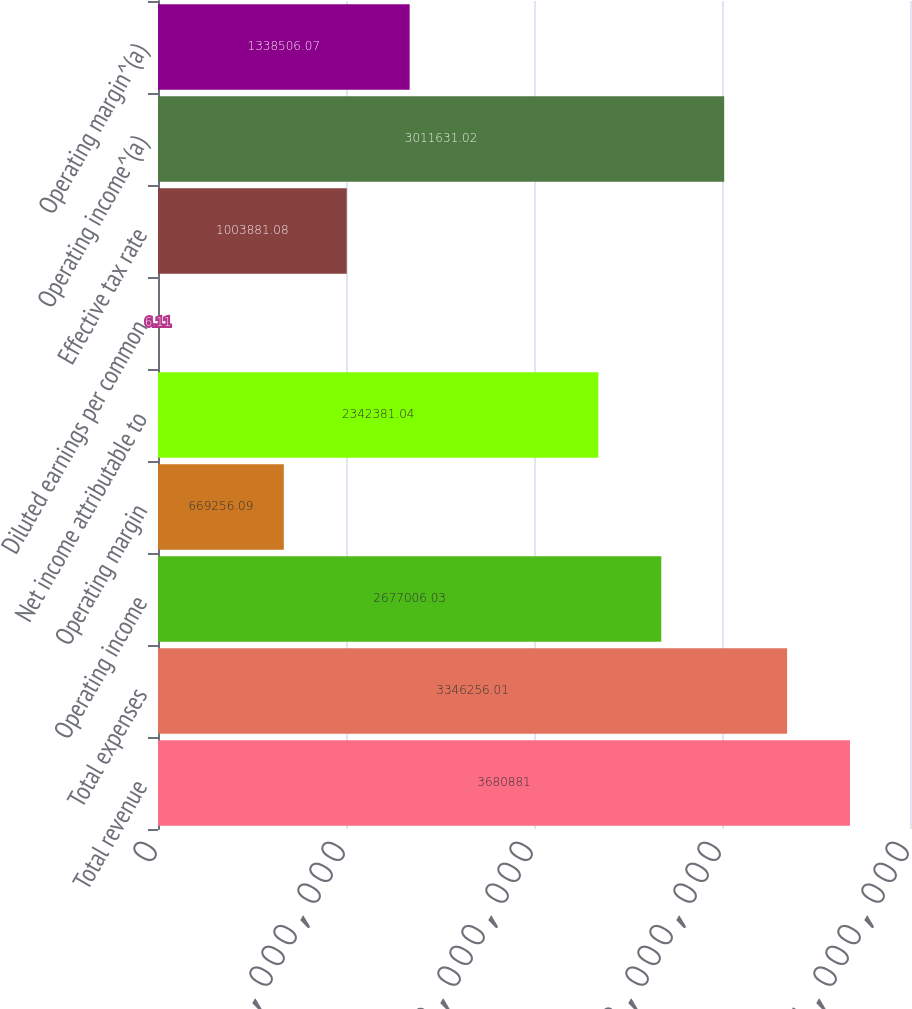Convert chart to OTSL. <chart><loc_0><loc_0><loc_500><loc_500><bar_chart><fcel>Total revenue<fcel>Total expenses<fcel>Operating income<fcel>Operating margin<fcel>Net income attributable to<fcel>Diluted earnings per common<fcel>Effective tax rate<fcel>Operating income^(a)<fcel>Operating margin^(a)<nl><fcel>3.68088e+06<fcel>3.34626e+06<fcel>2.67701e+06<fcel>669256<fcel>2.34238e+06<fcel>6.11<fcel>1.00388e+06<fcel>3.01163e+06<fcel>1.33851e+06<nl></chart> 